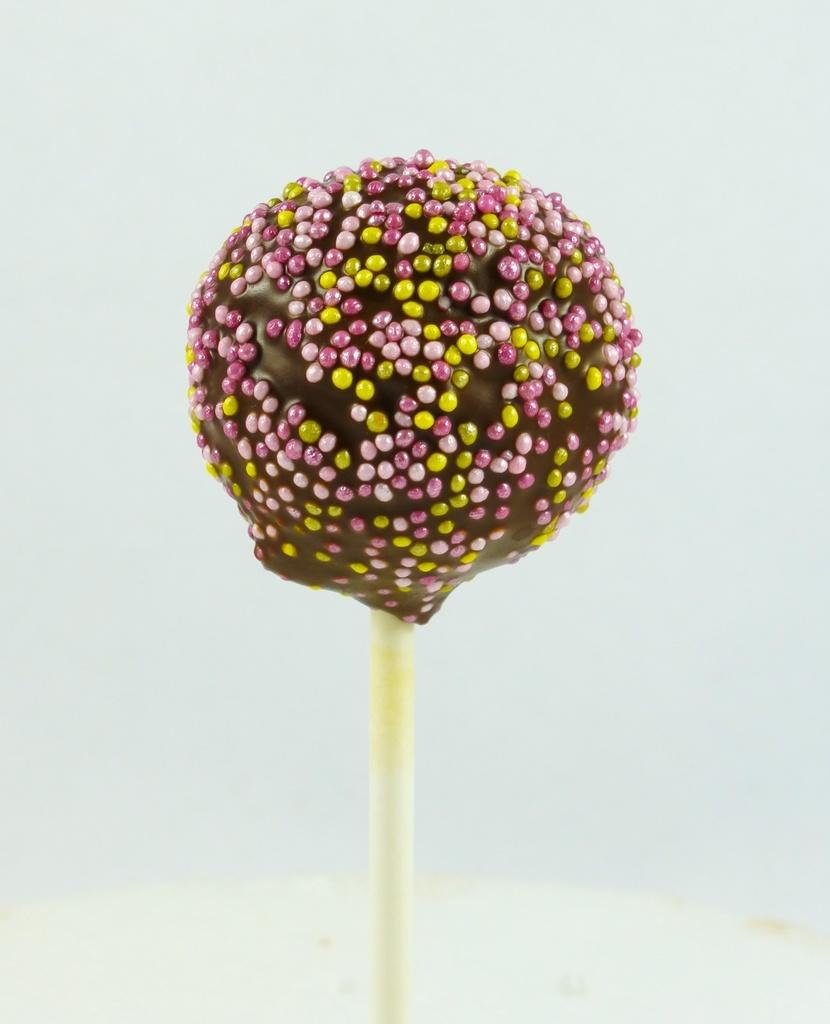What type of candy is present in the image? There is a lollipop in the image. What color is the cream on the lollipop? The cream on the lollipop has a brown color. What additional colors can be seen on the lollipop? There are yellow and pink color dots on the lollipop. How many snails are crawling on the lollipop in the image? There are no snails present in the image; it only features a lollipop with brown cream and yellow and pink dots. 